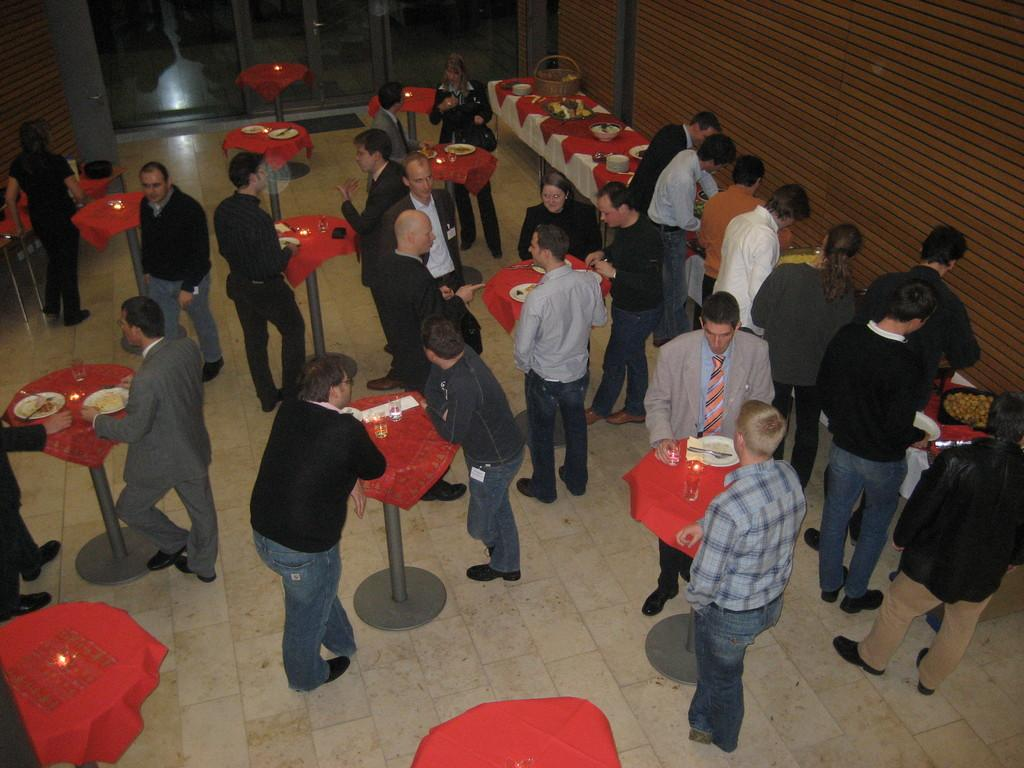What are the people in the image doing? The people in the image are on the floor. What can be seen in the image besides the people on the floor? There are tables, food items, and glasses visible in the image. What is the background of the image? There is a wall in the image. What type of pain is the person experiencing in the image? There is no indication of pain in the image; the people are simply on the floor. What loss has occurred in the image? There is no indication of loss in the image; the focus is on the people, tables, food items, glasses, and wall. 